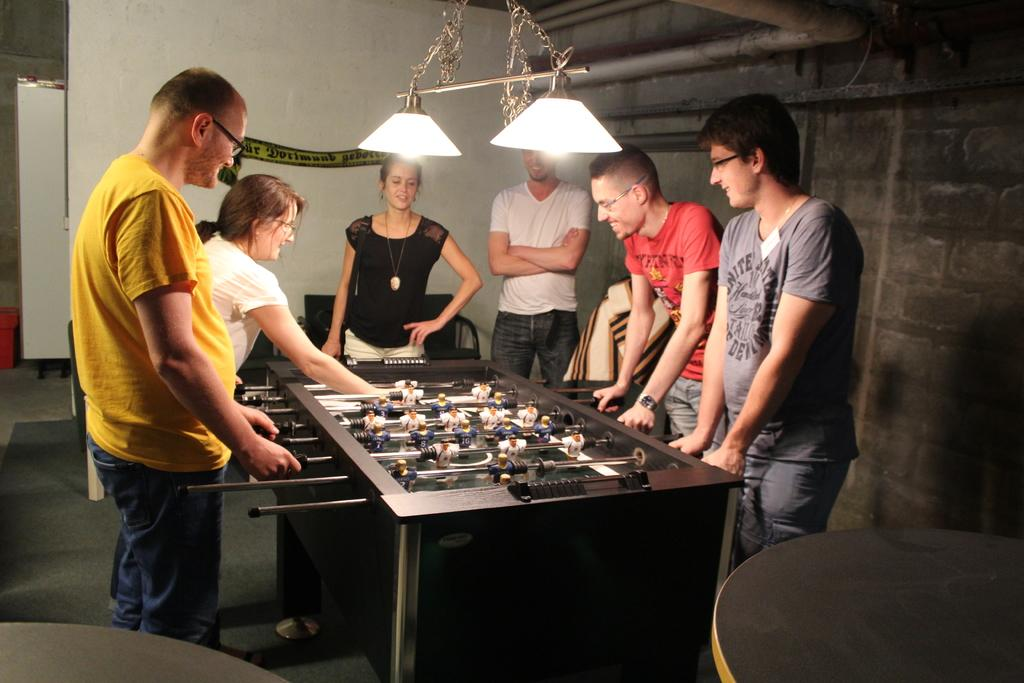What activity might the people near the Foosball table be engaged in? The people standing near the Foosball table might be playing or watching a game. What type of lighting is present in the image? There are electric lights visible in the image. What type of structure is depicted in the image? There are walls in the image, suggesting an indoor setting. What type of tent can be seen in the image? There is no tent present in the image. What kind of test is being conducted in the image? There is no test being conducted in the image; it features people near a Foosball table and electric lights. 